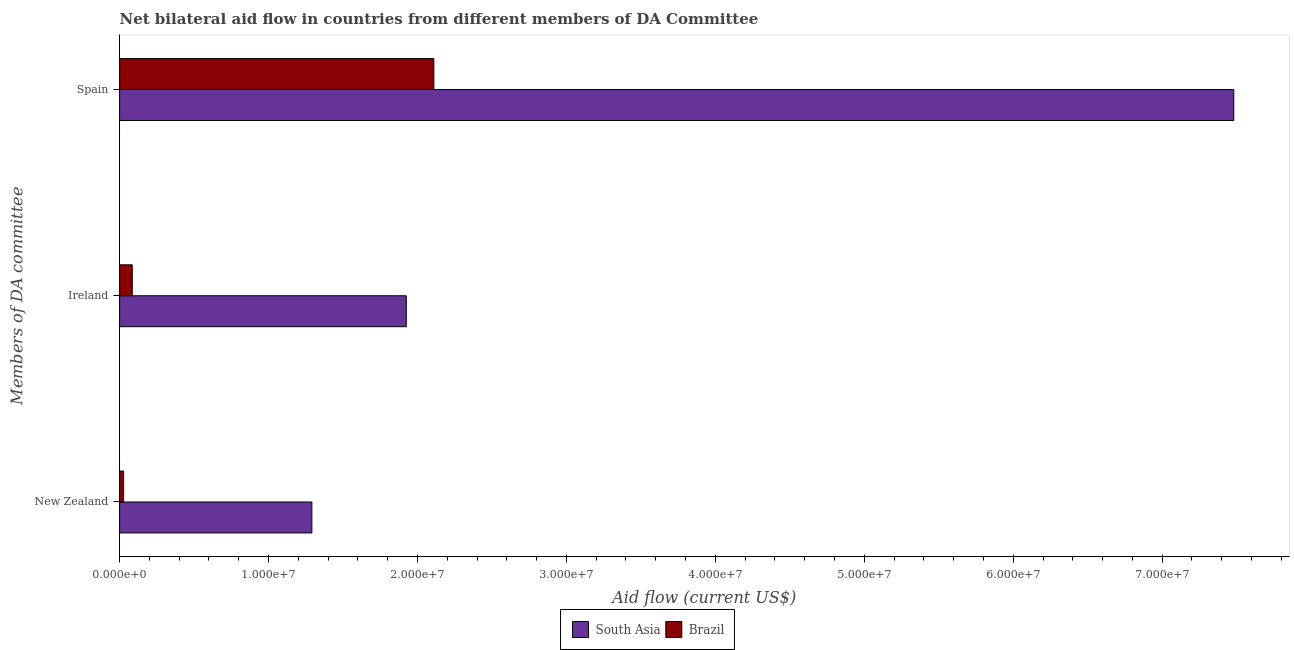Are the number of bars per tick equal to the number of legend labels?
Ensure brevity in your answer.  Yes. Are the number of bars on each tick of the Y-axis equal?
Offer a terse response. Yes. What is the label of the 1st group of bars from the top?
Your answer should be very brief. Spain. What is the amount of aid provided by ireland in Brazil?
Ensure brevity in your answer.  8.50e+05. Across all countries, what is the maximum amount of aid provided by ireland?
Offer a terse response. 1.92e+07. Across all countries, what is the minimum amount of aid provided by ireland?
Offer a terse response. 8.50e+05. In which country was the amount of aid provided by new zealand maximum?
Ensure brevity in your answer.  South Asia. What is the total amount of aid provided by spain in the graph?
Your response must be concise. 9.59e+07. What is the difference between the amount of aid provided by ireland in South Asia and that in Brazil?
Ensure brevity in your answer.  1.84e+07. What is the difference between the amount of aid provided by ireland in Brazil and the amount of aid provided by spain in South Asia?
Your answer should be compact. -7.40e+07. What is the average amount of aid provided by new zealand per country?
Provide a succinct answer. 6.59e+06. What is the difference between the amount of aid provided by spain and amount of aid provided by new zealand in Brazil?
Make the answer very short. 2.08e+07. In how many countries, is the amount of aid provided by new zealand greater than 8000000 US$?
Offer a very short reply. 1. What is the ratio of the amount of aid provided by ireland in South Asia to that in Brazil?
Your answer should be very brief. 22.65. Is the amount of aid provided by spain in South Asia less than that in Brazil?
Provide a short and direct response. No. Is the difference between the amount of aid provided by ireland in South Asia and Brazil greater than the difference between the amount of aid provided by spain in South Asia and Brazil?
Your answer should be compact. No. What is the difference between the highest and the second highest amount of aid provided by ireland?
Give a very brief answer. 1.84e+07. What is the difference between the highest and the lowest amount of aid provided by spain?
Give a very brief answer. 5.37e+07. In how many countries, is the amount of aid provided by spain greater than the average amount of aid provided by spain taken over all countries?
Ensure brevity in your answer.  1. What does the 2nd bar from the bottom in Spain represents?
Offer a very short reply. Brazil. Is it the case that in every country, the sum of the amount of aid provided by new zealand and amount of aid provided by ireland is greater than the amount of aid provided by spain?
Ensure brevity in your answer.  No. How many bars are there?
Provide a succinct answer. 6. Are all the bars in the graph horizontal?
Your response must be concise. Yes. What is the difference between two consecutive major ticks on the X-axis?
Offer a very short reply. 1.00e+07. Are the values on the major ticks of X-axis written in scientific E-notation?
Your answer should be very brief. Yes. Where does the legend appear in the graph?
Offer a very short reply. Bottom center. What is the title of the graph?
Provide a short and direct response. Net bilateral aid flow in countries from different members of DA Committee. What is the label or title of the X-axis?
Ensure brevity in your answer.  Aid flow (current US$). What is the label or title of the Y-axis?
Keep it short and to the point. Members of DA committee. What is the Aid flow (current US$) in South Asia in New Zealand?
Provide a short and direct response. 1.29e+07. What is the Aid flow (current US$) in South Asia in Ireland?
Your answer should be compact. 1.92e+07. What is the Aid flow (current US$) of Brazil in Ireland?
Offer a terse response. 8.50e+05. What is the Aid flow (current US$) in South Asia in Spain?
Offer a terse response. 7.48e+07. What is the Aid flow (current US$) of Brazil in Spain?
Ensure brevity in your answer.  2.11e+07. Across all Members of DA committee, what is the maximum Aid flow (current US$) of South Asia?
Ensure brevity in your answer.  7.48e+07. Across all Members of DA committee, what is the maximum Aid flow (current US$) in Brazil?
Provide a succinct answer. 2.11e+07. Across all Members of DA committee, what is the minimum Aid flow (current US$) in South Asia?
Your response must be concise. 1.29e+07. What is the total Aid flow (current US$) of South Asia in the graph?
Provide a short and direct response. 1.07e+08. What is the total Aid flow (current US$) in Brazil in the graph?
Offer a very short reply. 2.22e+07. What is the difference between the Aid flow (current US$) of South Asia in New Zealand and that in Ireland?
Make the answer very short. -6.34e+06. What is the difference between the Aid flow (current US$) in Brazil in New Zealand and that in Ireland?
Offer a terse response. -5.80e+05. What is the difference between the Aid flow (current US$) of South Asia in New Zealand and that in Spain?
Your response must be concise. -6.19e+07. What is the difference between the Aid flow (current US$) in Brazil in New Zealand and that in Spain?
Your answer should be compact. -2.08e+07. What is the difference between the Aid flow (current US$) in South Asia in Ireland and that in Spain?
Ensure brevity in your answer.  -5.56e+07. What is the difference between the Aid flow (current US$) of Brazil in Ireland and that in Spain?
Keep it short and to the point. -2.02e+07. What is the difference between the Aid flow (current US$) of South Asia in New Zealand and the Aid flow (current US$) of Brazil in Ireland?
Provide a short and direct response. 1.21e+07. What is the difference between the Aid flow (current US$) of South Asia in New Zealand and the Aid flow (current US$) of Brazil in Spain?
Offer a terse response. -8.19e+06. What is the difference between the Aid flow (current US$) of South Asia in Ireland and the Aid flow (current US$) of Brazil in Spain?
Offer a very short reply. -1.85e+06. What is the average Aid flow (current US$) in South Asia per Members of DA committee?
Offer a terse response. 3.57e+07. What is the average Aid flow (current US$) in Brazil per Members of DA committee?
Give a very brief answer. 7.41e+06. What is the difference between the Aid flow (current US$) in South Asia and Aid flow (current US$) in Brazil in New Zealand?
Keep it short and to the point. 1.26e+07. What is the difference between the Aid flow (current US$) of South Asia and Aid flow (current US$) of Brazil in Ireland?
Ensure brevity in your answer.  1.84e+07. What is the difference between the Aid flow (current US$) in South Asia and Aid flow (current US$) in Brazil in Spain?
Provide a succinct answer. 5.37e+07. What is the ratio of the Aid flow (current US$) of South Asia in New Zealand to that in Ireland?
Offer a terse response. 0.67. What is the ratio of the Aid flow (current US$) in Brazil in New Zealand to that in Ireland?
Your answer should be compact. 0.32. What is the ratio of the Aid flow (current US$) in South Asia in New Zealand to that in Spain?
Your response must be concise. 0.17. What is the ratio of the Aid flow (current US$) of Brazil in New Zealand to that in Spain?
Make the answer very short. 0.01. What is the ratio of the Aid flow (current US$) in South Asia in Ireland to that in Spain?
Provide a succinct answer. 0.26. What is the ratio of the Aid flow (current US$) in Brazil in Ireland to that in Spain?
Give a very brief answer. 0.04. What is the difference between the highest and the second highest Aid flow (current US$) in South Asia?
Make the answer very short. 5.56e+07. What is the difference between the highest and the second highest Aid flow (current US$) in Brazil?
Offer a terse response. 2.02e+07. What is the difference between the highest and the lowest Aid flow (current US$) in South Asia?
Give a very brief answer. 6.19e+07. What is the difference between the highest and the lowest Aid flow (current US$) of Brazil?
Provide a short and direct response. 2.08e+07. 